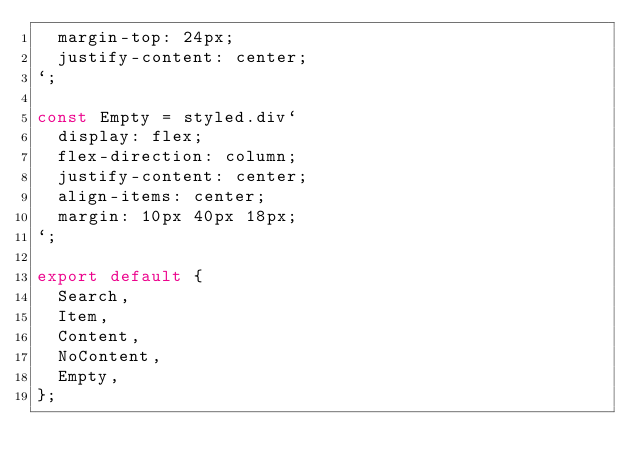Convert code to text. <code><loc_0><loc_0><loc_500><loc_500><_TypeScript_>  margin-top: 24px;
  justify-content: center;
`;

const Empty = styled.div`
  display: flex;
  flex-direction: column;
  justify-content: center;
  align-items: center;
  margin: 10px 40px 18px;
`;

export default {
  Search,
  Item,
  Content,
  NoContent,
  Empty,
};
</code> 